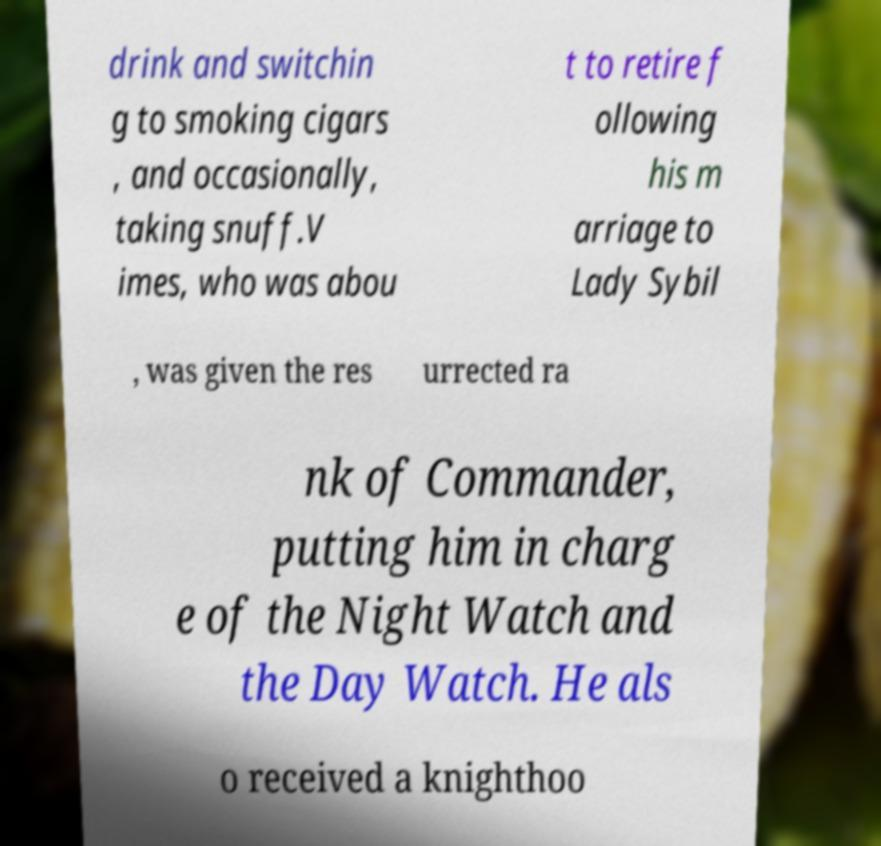There's text embedded in this image that I need extracted. Can you transcribe it verbatim? drink and switchin g to smoking cigars , and occasionally, taking snuff.V imes, who was abou t to retire f ollowing his m arriage to Lady Sybil , was given the res urrected ra nk of Commander, putting him in charg e of the Night Watch and the Day Watch. He als o received a knighthoo 